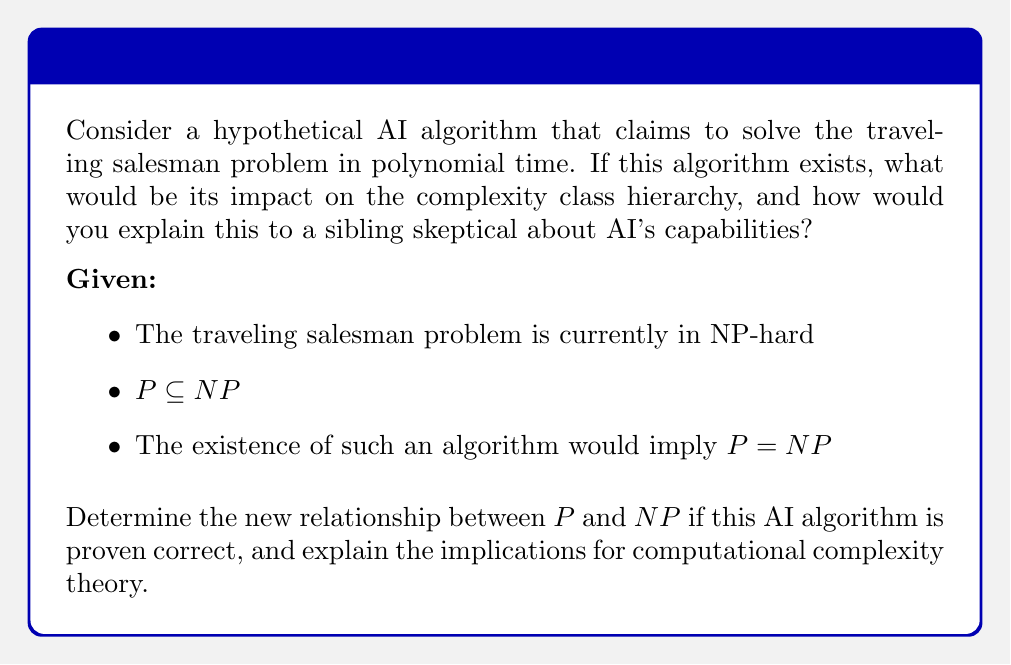What is the answer to this math problem? To understand the impact of this hypothetical AI algorithm, let's break down the problem step-by-step:

1) Current state of complexity classes:
   - P: problems solvable in polynomial time
   - NP: problems verifiable in polynomial time
   - NP-hard: problems at least as hard as the hardest problems in NP

2) The traveling salesman problem (TSP) is known to be NP-hard. This means it's at least as hard as any problem in NP.

3) If an AI algorithm solves TSP in polynomial time, it implies:
   $$\text{TSP} \in \text{P}$$

4) Since TSP is NP-hard, this would mean that all problems in NP can be reduced to TSP in polynomial time, and thus:
   $$\text{NP} \subseteq \text{P}$$

5) We already know that:
   $$\text{P} \subseteq \text{NP}$$

6) Combining (4) and (5), we get:
   $$\text{P} = \text{NP}$$

7) Implications:
   - All NP problems would be solvable in polynomial time
   - The distinction between easy-to-solve and easy-to-verify problems would collapse
   - Many cryptographic systems based on the hardness of NP problems would be compromised

8) For a skeptical sibling:
   - Explain that this would be like finding a way to solve all puzzle games instantly
   - It would change our understanding of what computers can do efficiently
   - However, emphasize that this is still a hypothetical scenario and hasn't been proven

9) Computational complexity impact:
   - The complexity hierarchy would dramatically simplify
   - Many open problems in computer science would be resolved
   - New, harder complexity classes would become the focus of research
Answer: If the AI algorithm is proven correct, P = NP. This would collapse the distinction between P and NP, revolutionizing computational complexity theory and potentially compromising many current cryptographic systems. 